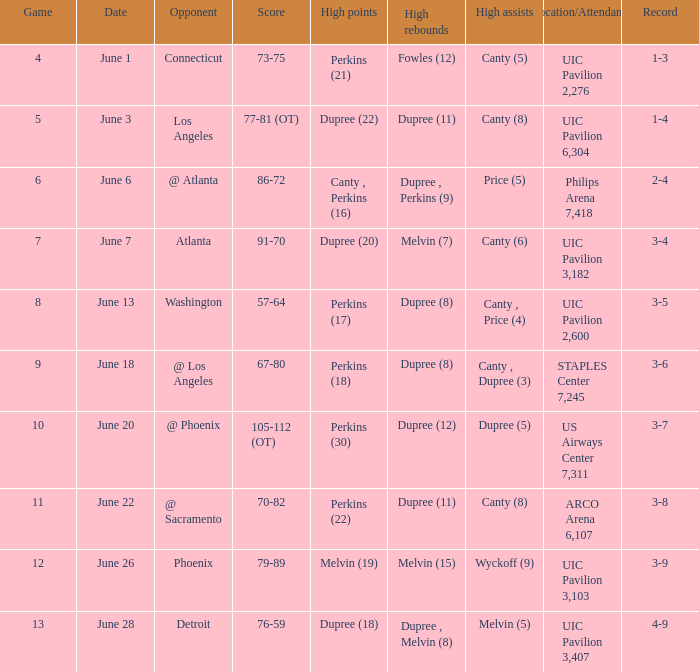When is game 9 taking place? June 18. 